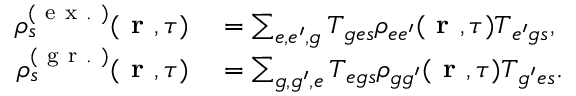<formula> <loc_0><loc_0><loc_500><loc_500>\begin{array} { r l } { \rho _ { s } ^ { ( e x . ) } ( r , \tau ) } & = \sum _ { e , e ^ { \prime } , g } T _ { { g e } s } \rho _ { { e e ^ { \prime } } } ( r , \tau ) T _ { { e ^ { \prime } g } s } , } \\ { \rho _ { s } ^ { ( g r . ) } ( r , \tau ) } & = \sum _ { g , g ^ { \prime } , e } T _ { { e g } s } \rho _ { { g g ^ { \prime } } } ( r , \tau ) T _ { { g ^ { \prime } e } s } . } \end{array}</formula> 